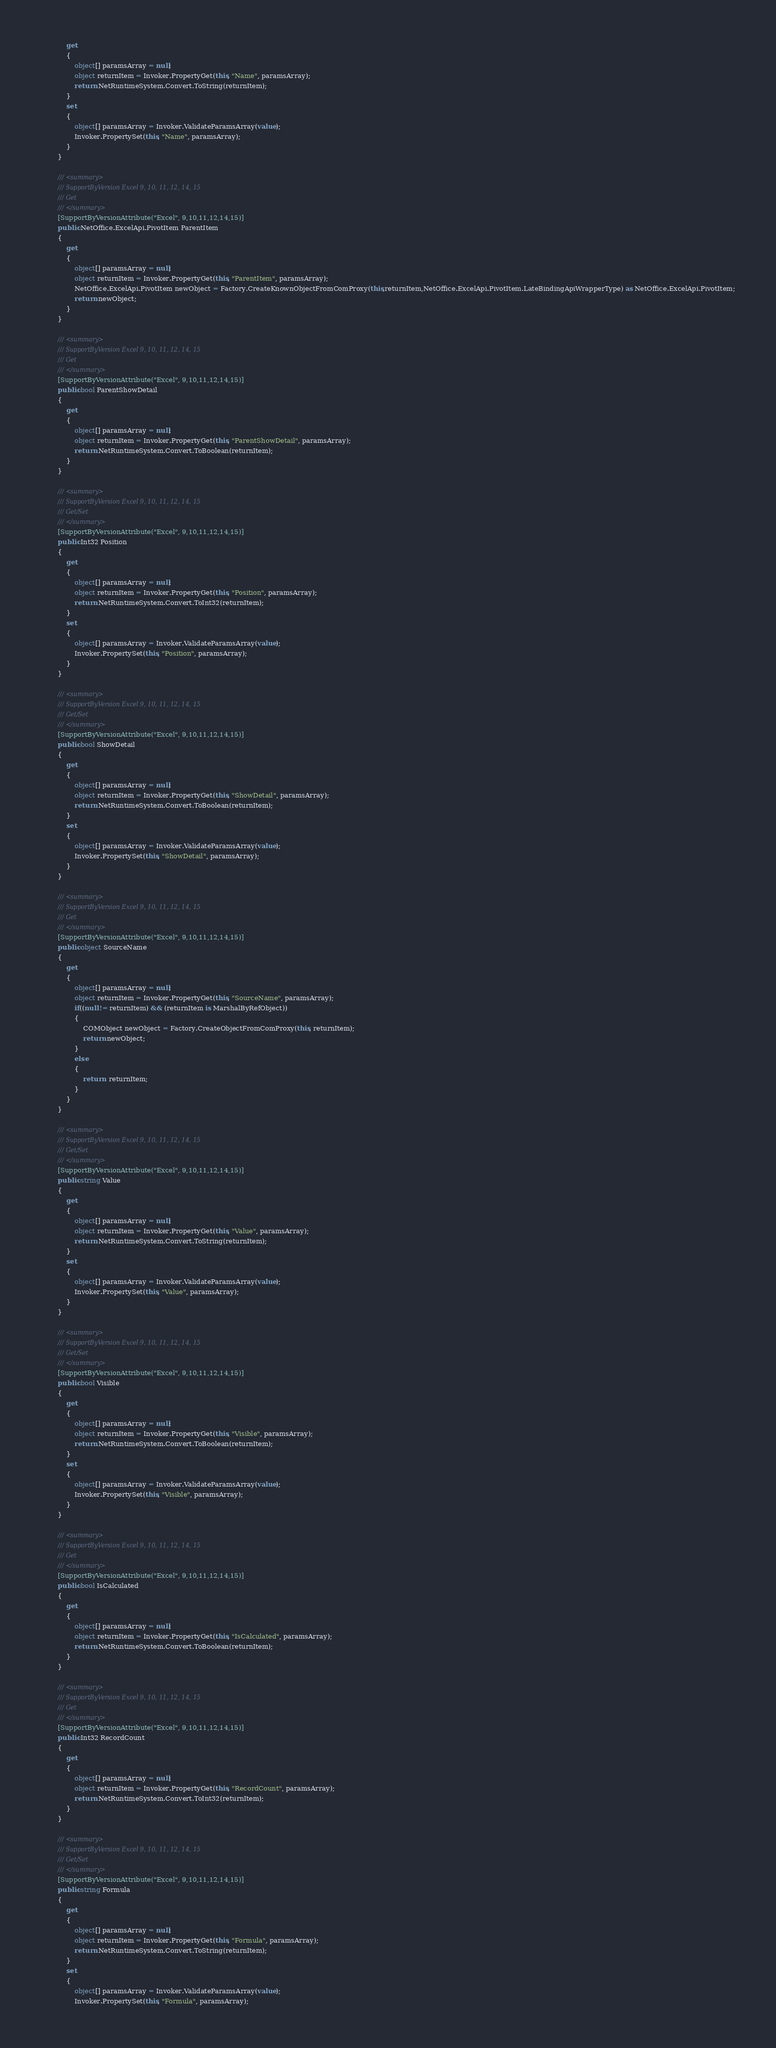<code> <loc_0><loc_0><loc_500><loc_500><_C#_>			get
			{
				object[] paramsArray = null;
				object returnItem = Invoker.PropertyGet(this, "Name", paramsArray);
				return NetRuntimeSystem.Convert.ToString(returnItem);
			}
			set
			{
				object[] paramsArray = Invoker.ValidateParamsArray(value);
				Invoker.PropertySet(this, "Name", paramsArray);
			}
		}

		/// <summary>
		/// SupportByVersion Excel 9, 10, 11, 12, 14, 15
		/// Get
		/// </summary>
		[SupportByVersionAttribute("Excel", 9,10,11,12,14,15)]
		public NetOffice.ExcelApi.PivotItem ParentItem
		{
			get
			{
				object[] paramsArray = null;
				object returnItem = Invoker.PropertyGet(this, "ParentItem", paramsArray);
				NetOffice.ExcelApi.PivotItem newObject = Factory.CreateKnownObjectFromComProxy(this,returnItem,NetOffice.ExcelApi.PivotItem.LateBindingApiWrapperType) as NetOffice.ExcelApi.PivotItem;
				return newObject;
			}
		}

		/// <summary>
		/// SupportByVersion Excel 9, 10, 11, 12, 14, 15
		/// Get
		/// </summary>
		[SupportByVersionAttribute("Excel", 9,10,11,12,14,15)]
		public bool ParentShowDetail
		{
			get
			{
				object[] paramsArray = null;
				object returnItem = Invoker.PropertyGet(this, "ParentShowDetail", paramsArray);
				return NetRuntimeSystem.Convert.ToBoolean(returnItem);
			}
		}

		/// <summary>
		/// SupportByVersion Excel 9, 10, 11, 12, 14, 15
		/// Get/Set
		/// </summary>
		[SupportByVersionAttribute("Excel", 9,10,11,12,14,15)]
		public Int32 Position
		{
			get
			{
				object[] paramsArray = null;
				object returnItem = Invoker.PropertyGet(this, "Position", paramsArray);
				return NetRuntimeSystem.Convert.ToInt32(returnItem);
			}
			set
			{
				object[] paramsArray = Invoker.ValidateParamsArray(value);
				Invoker.PropertySet(this, "Position", paramsArray);
			}
		}

		/// <summary>
		/// SupportByVersion Excel 9, 10, 11, 12, 14, 15
		/// Get/Set
		/// </summary>
		[SupportByVersionAttribute("Excel", 9,10,11,12,14,15)]
		public bool ShowDetail
		{
			get
			{
				object[] paramsArray = null;
				object returnItem = Invoker.PropertyGet(this, "ShowDetail", paramsArray);
				return NetRuntimeSystem.Convert.ToBoolean(returnItem);
			}
			set
			{
				object[] paramsArray = Invoker.ValidateParamsArray(value);
				Invoker.PropertySet(this, "ShowDetail", paramsArray);
			}
		}

		/// <summary>
		/// SupportByVersion Excel 9, 10, 11, 12, 14, 15
		/// Get
		/// </summary>
		[SupportByVersionAttribute("Excel", 9,10,11,12,14,15)]
		public object SourceName
		{
			get
			{
				object[] paramsArray = null;
				object returnItem = Invoker.PropertyGet(this, "SourceName", paramsArray);
				if((null != returnItem) && (returnItem is MarshalByRefObject))
				{
					COMObject newObject = Factory.CreateObjectFromComProxy(this, returnItem);
					return newObject;
				}
				else
				{
					return  returnItem;
				}
			}
		}

		/// <summary>
		/// SupportByVersion Excel 9, 10, 11, 12, 14, 15
		/// Get/Set
		/// </summary>
		[SupportByVersionAttribute("Excel", 9,10,11,12,14,15)]
		public string Value
		{
			get
			{
				object[] paramsArray = null;
				object returnItem = Invoker.PropertyGet(this, "Value", paramsArray);
				return NetRuntimeSystem.Convert.ToString(returnItem);
			}
			set
			{
				object[] paramsArray = Invoker.ValidateParamsArray(value);
				Invoker.PropertySet(this, "Value", paramsArray);
			}
		}

		/// <summary>
		/// SupportByVersion Excel 9, 10, 11, 12, 14, 15
		/// Get/Set
		/// </summary>
		[SupportByVersionAttribute("Excel", 9,10,11,12,14,15)]
		public bool Visible
		{
			get
			{
				object[] paramsArray = null;
				object returnItem = Invoker.PropertyGet(this, "Visible", paramsArray);
				return NetRuntimeSystem.Convert.ToBoolean(returnItem);
			}
			set
			{
				object[] paramsArray = Invoker.ValidateParamsArray(value);
				Invoker.PropertySet(this, "Visible", paramsArray);
			}
		}

		/// <summary>
		/// SupportByVersion Excel 9, 10, 11, 12, 14, 15
		/// Get
		/// </summary>
		[SupportByVersionAttribute("Excel", 9,10,11,12,14,15)]
		public bool IsCalculated
		{
			get
			{
				object[] paramsArray = null;
				object returnItem = Invoker.PropertyGet(this, "IsCalculated", paramsArray);
				return NetRuntimeSystem.Convert.ToBoolean(returnItem);
			}
		}

		/// <summary>
		/// SupportByVersion Excel 9, 10, 11, 12, 14, 15
		/// Get
		/// </summary>
		[SupportByVersionAttribute("Excel", 9,10,11,12,14,15)]
		public Int32 RecordCount
		{
			get
			{
				object[] paramsArray = null;
				object returnItem = Invoker.PropertyGet(this, "RecordCount", paramsArray);
				return NetRuntimeSystem.Convert.ToInt32(returnItem);
			}
		}

		/// <summary>
		/// SupportByVersion Excel 9, 10, 11, 12, 14, 15
		/// Get/Set
		/// </summary>
		[SupportByVersionAttribute("Excel", 9,10,11,12,14,15)]
		public string Formula
		{
			get
			{
				object[] paramsArray = null;
				object returnItem = Invoker.PropertyGet(this, "Formula", paramsArray);
				return NetRuntimeSystem.Convert.ToString(returnItem);
			}
			set
			{
				object[] paramsArray = Invoker.ValidateParamsArray(value);
				Invoker.PropertySet(this, "Formula", paramsArray);</code> 